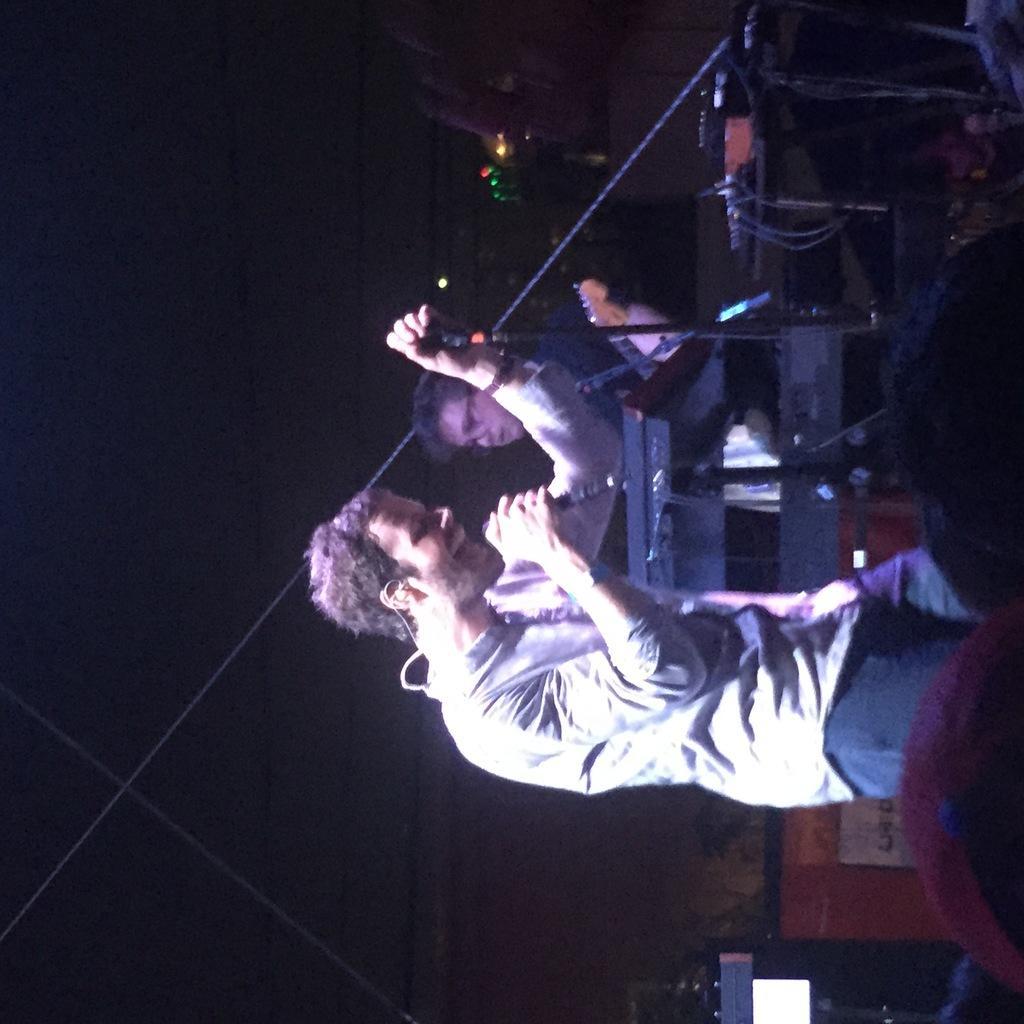How would you summarize this image in a sentence or two? In this image there are few people standing on the stage, in which one of them holding microphone and other one is playing musical instruments. 